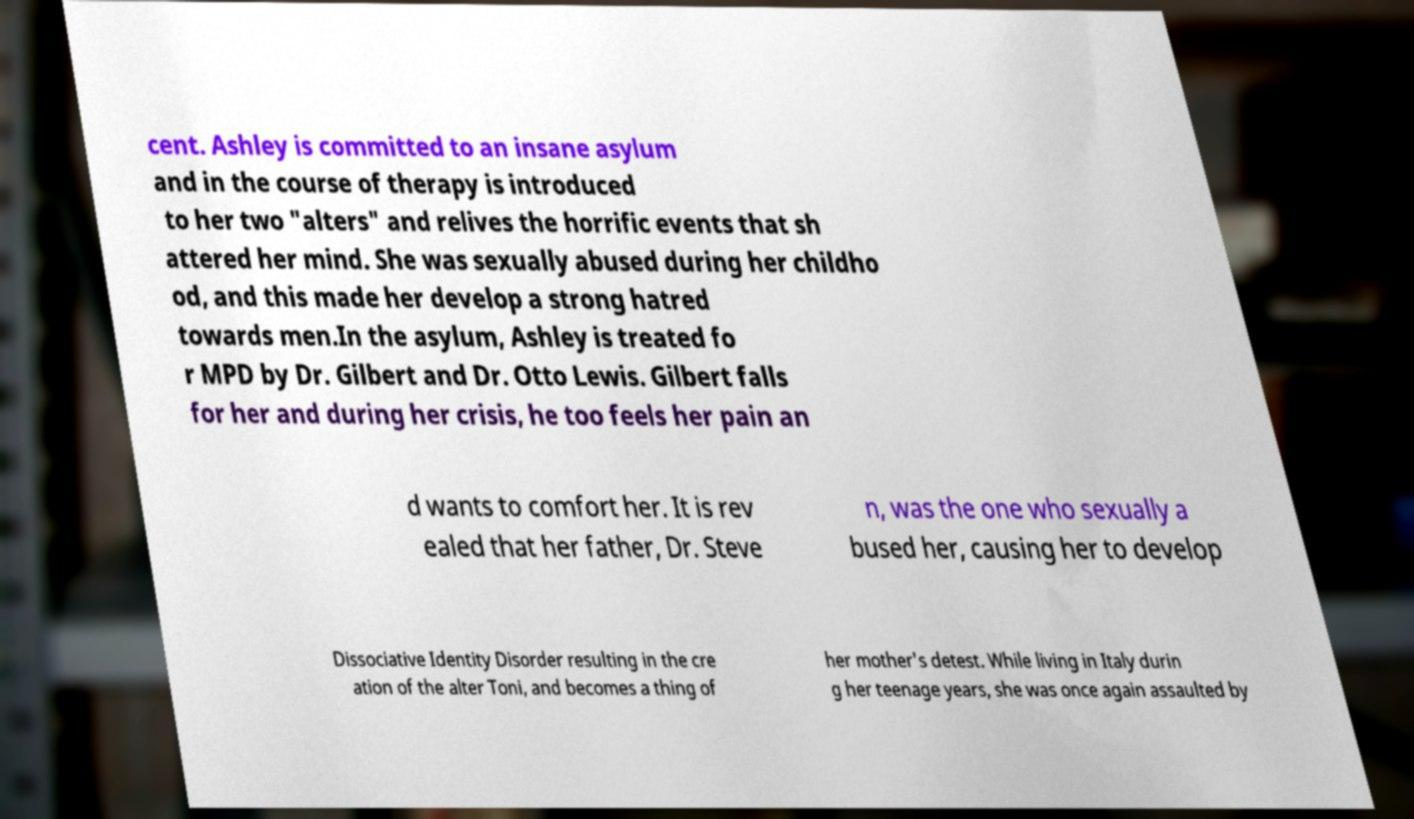Could you assist in decoding the text presented in this image and type it out clearly? cent. Ashley is committed to an insane asylum and in the course of therapy is introduced to her two "alters" and relives the horrific events that sh attered her mind. She was sexually abused during her childho od, and this made her develop a strong hatred towards men.In the asylum, Ashley is treated fo r MPD by Dr. Gilbert and Dr. Otto Lewis. Gilbert falls for her and during her crisis, he too feels her pain an d wants to comfort her. It is rev ealed that her father, Dr. Steve n, was the one who sexually a bused her, causing her to develop Dissociative Identity Disorder resulting in the cre ation of the alter Toni, and becomes a thing of her mother's detest. While living in Italy durin g her teenage years, she was once again assaulted by 